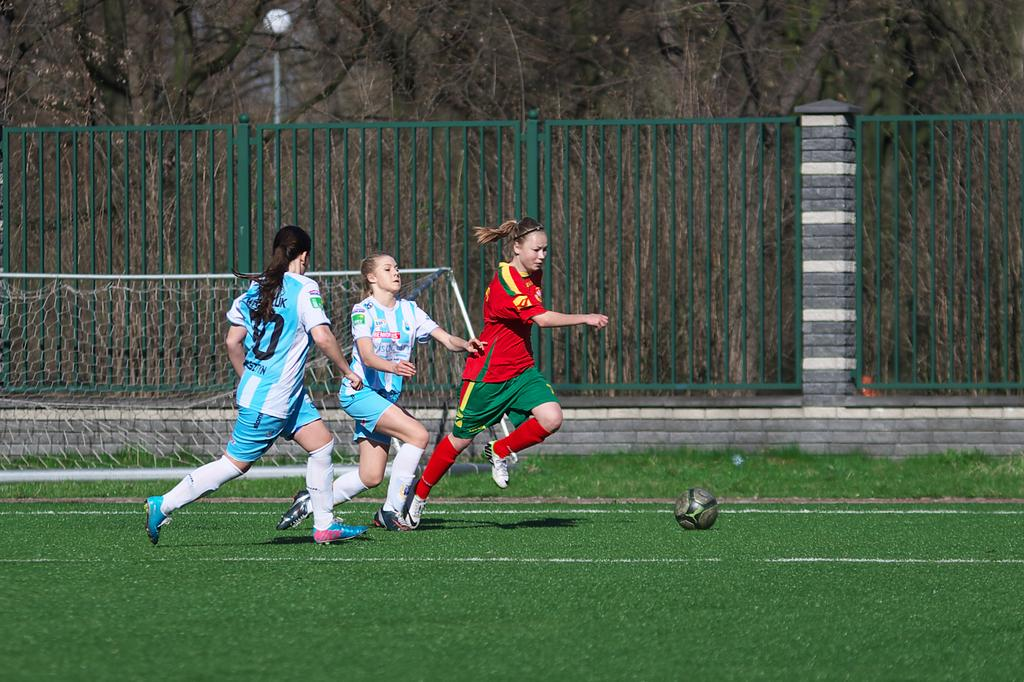<image>
Create a compact narrative representing the image presented. a girl playing soccer in blue with the number 0 on her back 